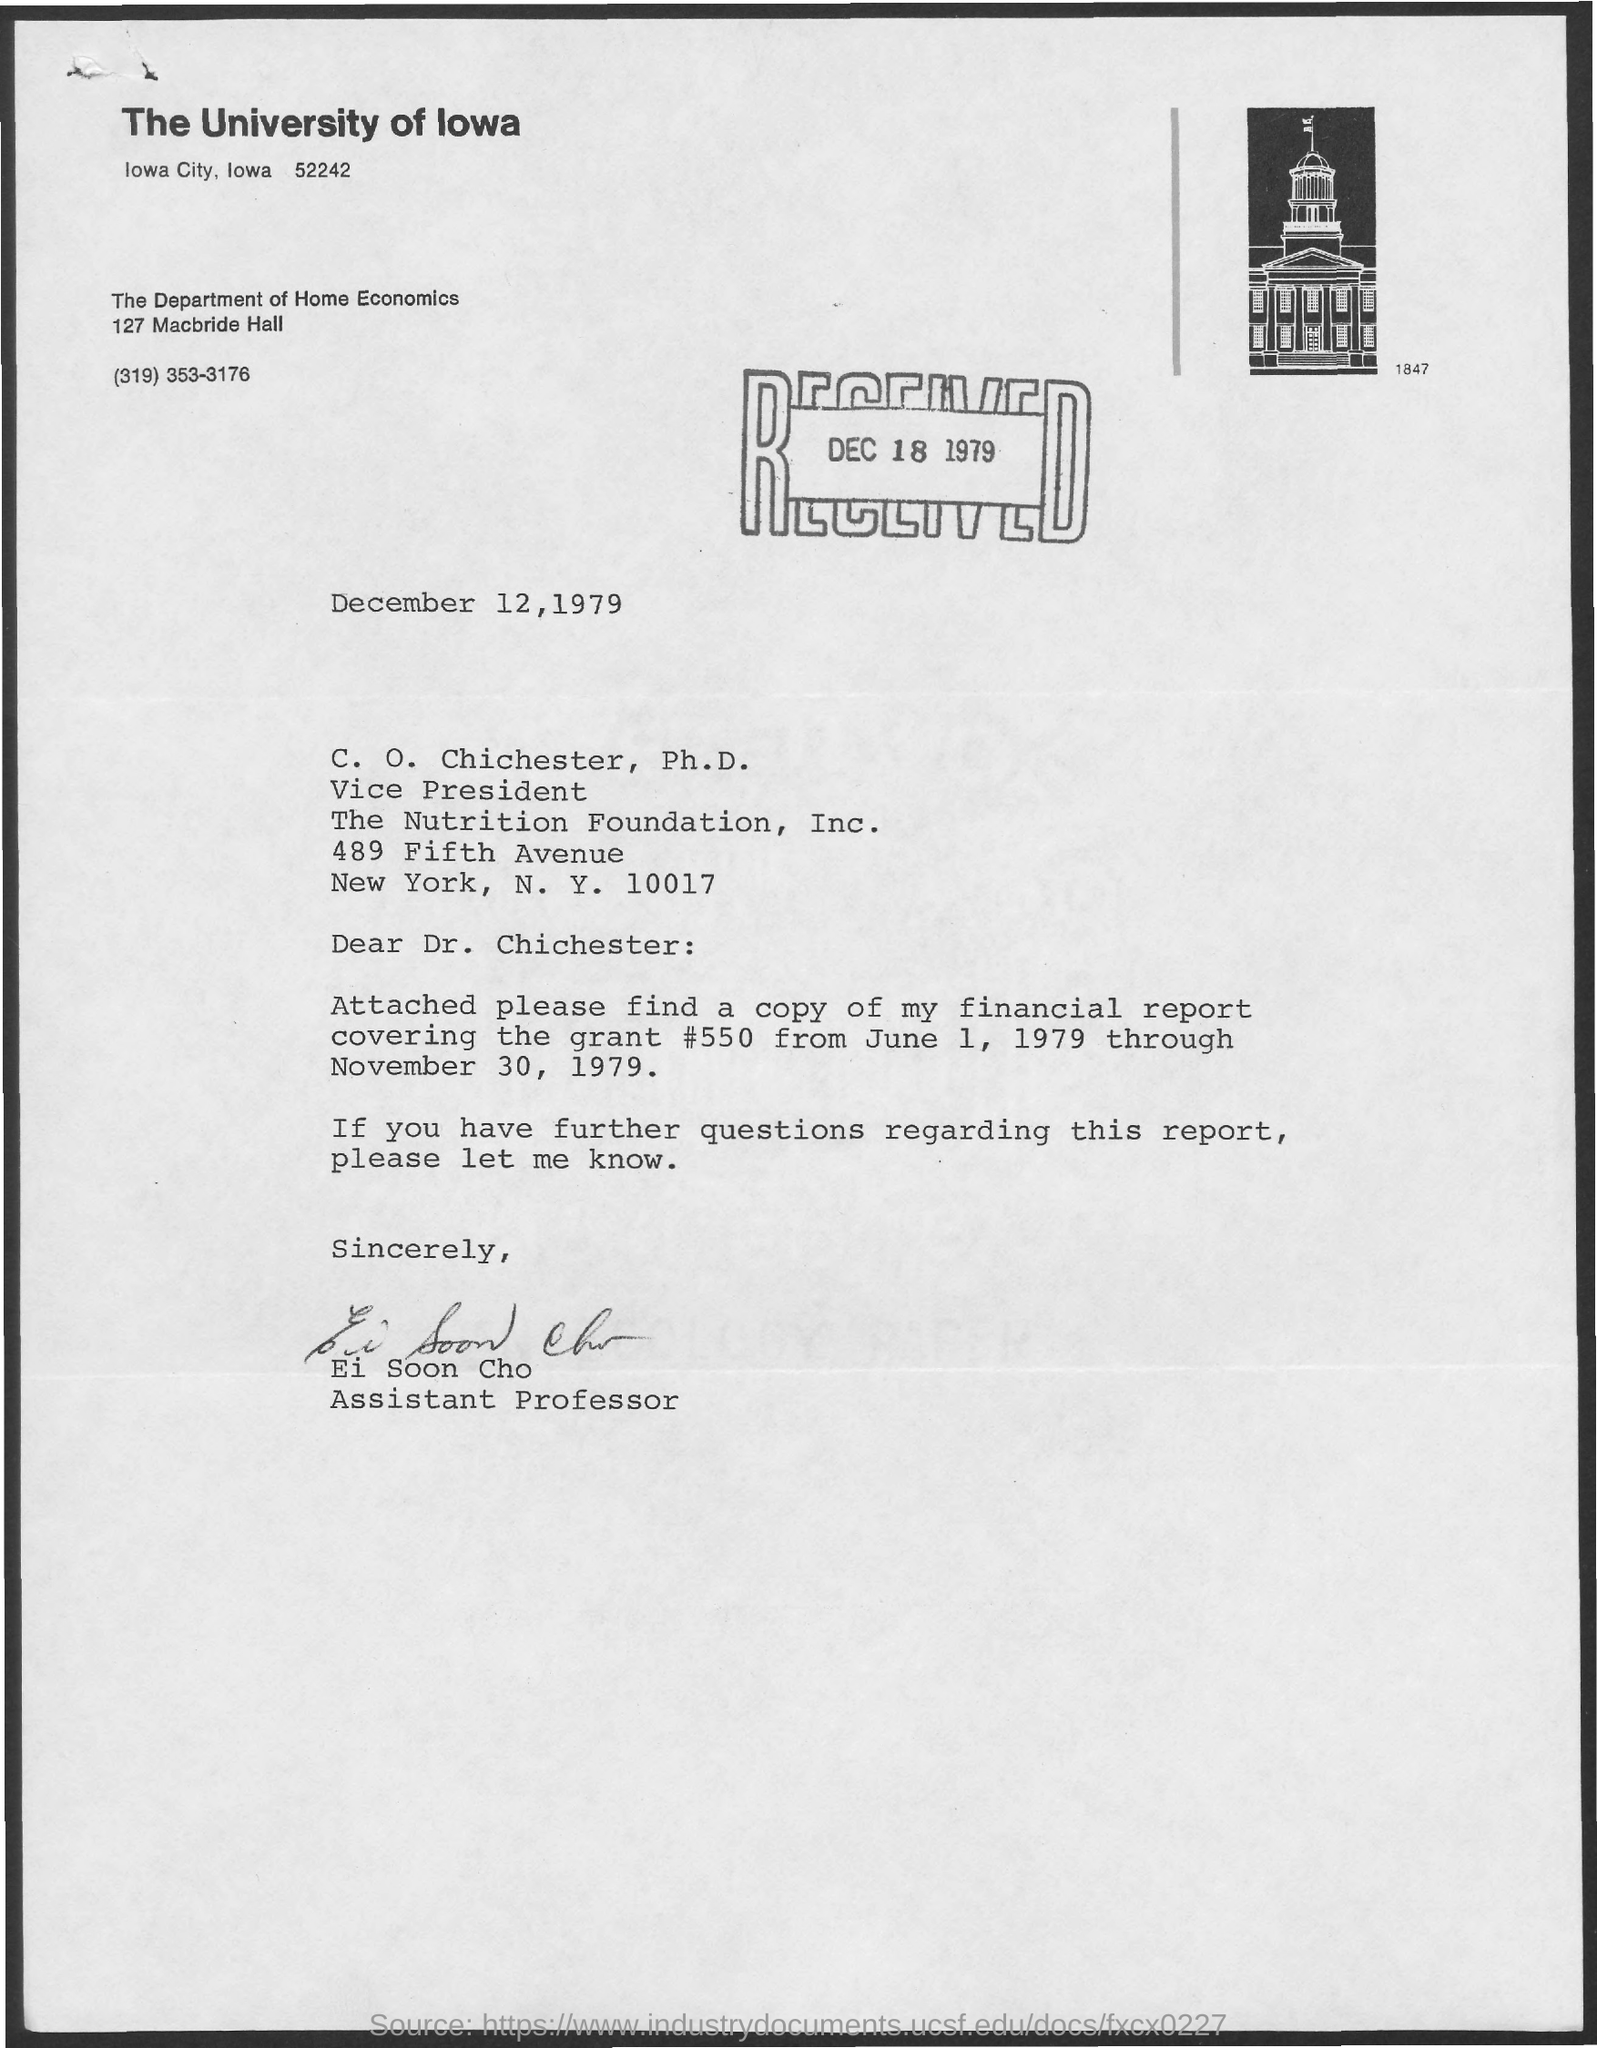Highlight a few significant elements in this photo. The letter is addressed to C. O. Chichester, Ph.D. The sender of this letter is Ei Soon Cho. The delivery was received on December 18, 1979. 